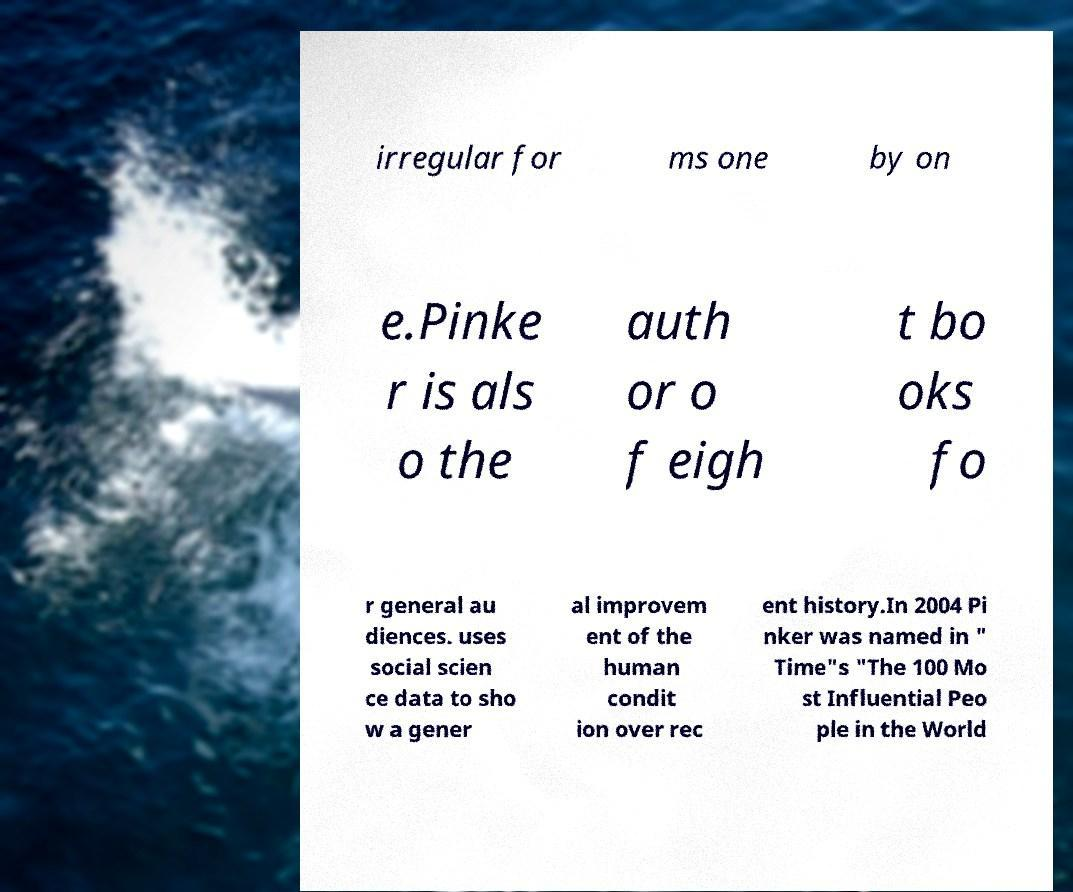Can you accurately transcribe the text from the provided image for me? irregular for ms one by on e.Pinke r is als o the auth or o f eigh t bo oks fo r general au diences. uses social scien ce data to sho w a gener al improvem ent of the human condit ion over rec ent history.In 2004 Pi nker was named in " Time"s "The 100 Mo st Influential Peo ple in the World 